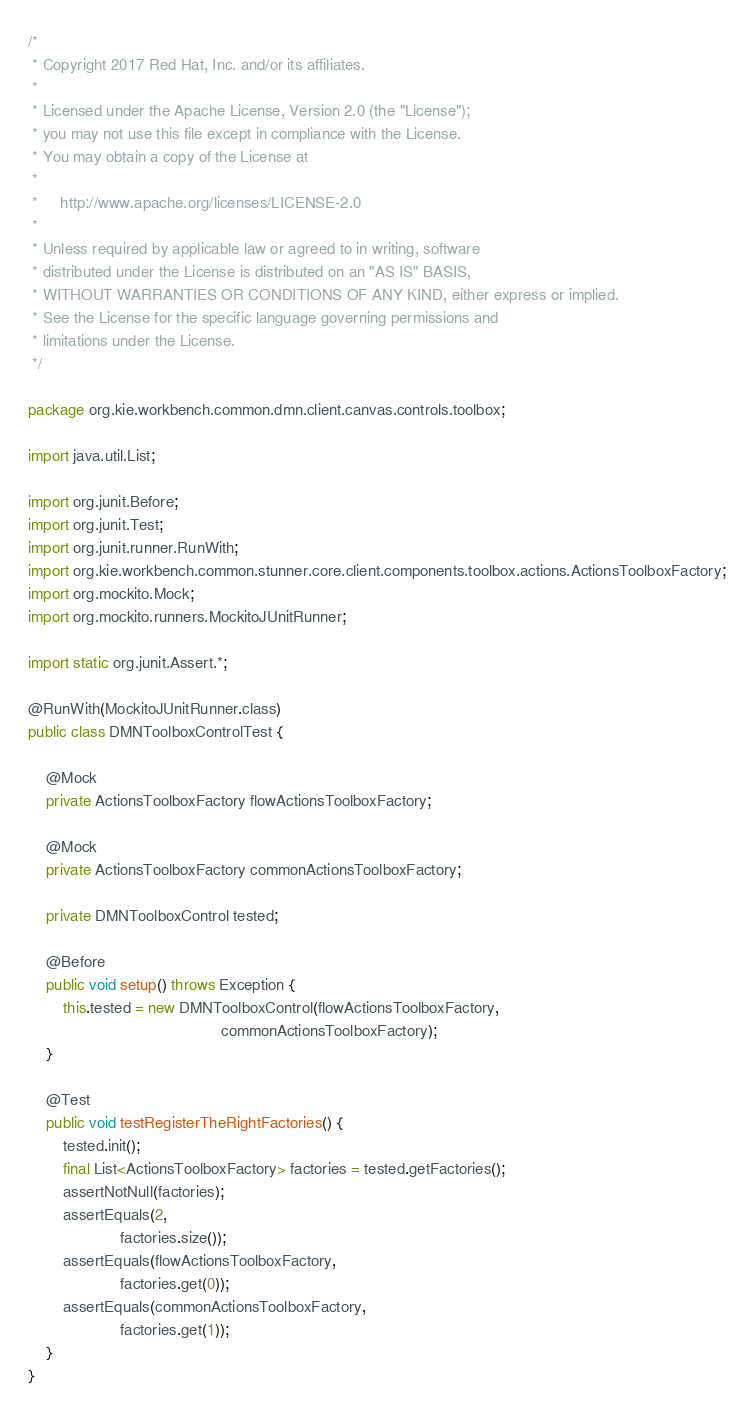<code> <loc_0><loc_0><loc_500><loc_500><_Java_>/*
 * Copyright 2017 Red Hat, Inc. and/or its affiliates.
 *
 * Licensed under the Apache License, Version 2.0 (the "License");
 * you may not use this file except in compliance with the License.
 * You may obtain a copy of the License at
 *
 *     http://www.apache.org/licenses/LICENSE-2.0
 *
 * Unless required by applicable law or agreed to in writing, software
 * distributed under the License is distributed on an "AS IS" BASIS,
 * WITHOUT WARRANTIES OR CONDITIONS OF ANY KIND, either express or implied.
 * See the License for the specific language governing permissions and
 * limitations under the License.
 */

package org.kie.workbench.common.dmn.client.canvas.controls.toolbox;

import java.util.List;

import org.junit.Before;
import org.junit.Test;
import org.junit.runner.RunWith;
import org.kie.workbench.common.stunner.core.client.components.toolbox.actions.ActionsToolboxFactory;
import org.mockito.Mock;
import org.mockito.runners.MockitoJUnitRunner;

import static org.junit.Assert.*;

@RunWith(MockitoJUnitRunner.class)
public class DMNToolboxControlTest {

    @Mock
    private ActionsToolboxFactory flowActionsToolboxFactory;

    @Mock
    private ActionsToolboxFactory commonActionsToolboxFactory;

    private DMNToolboxControl tested;

    @Before
    public void setup() throws Exception {
        this.tested = new DMNToolboxControl(flowActionsToolboxFactory,
                                            commonActionsToolboxFactory);
    }

    @Test
    public void testRegisterTheRightFactories() {
        tested.init();
        final List<ActionsToolboxFactory> factories = tested.getFactories();
        assertNotNull(factories);
        assertEquals(2,
                     factories.size());
        assertEquals(flowActionsToolboxFactory,
                     factories.get(0));
        assertEquals(commonActionsToolboxFactory,
                     factories.get(1));
    }
}
</code> 